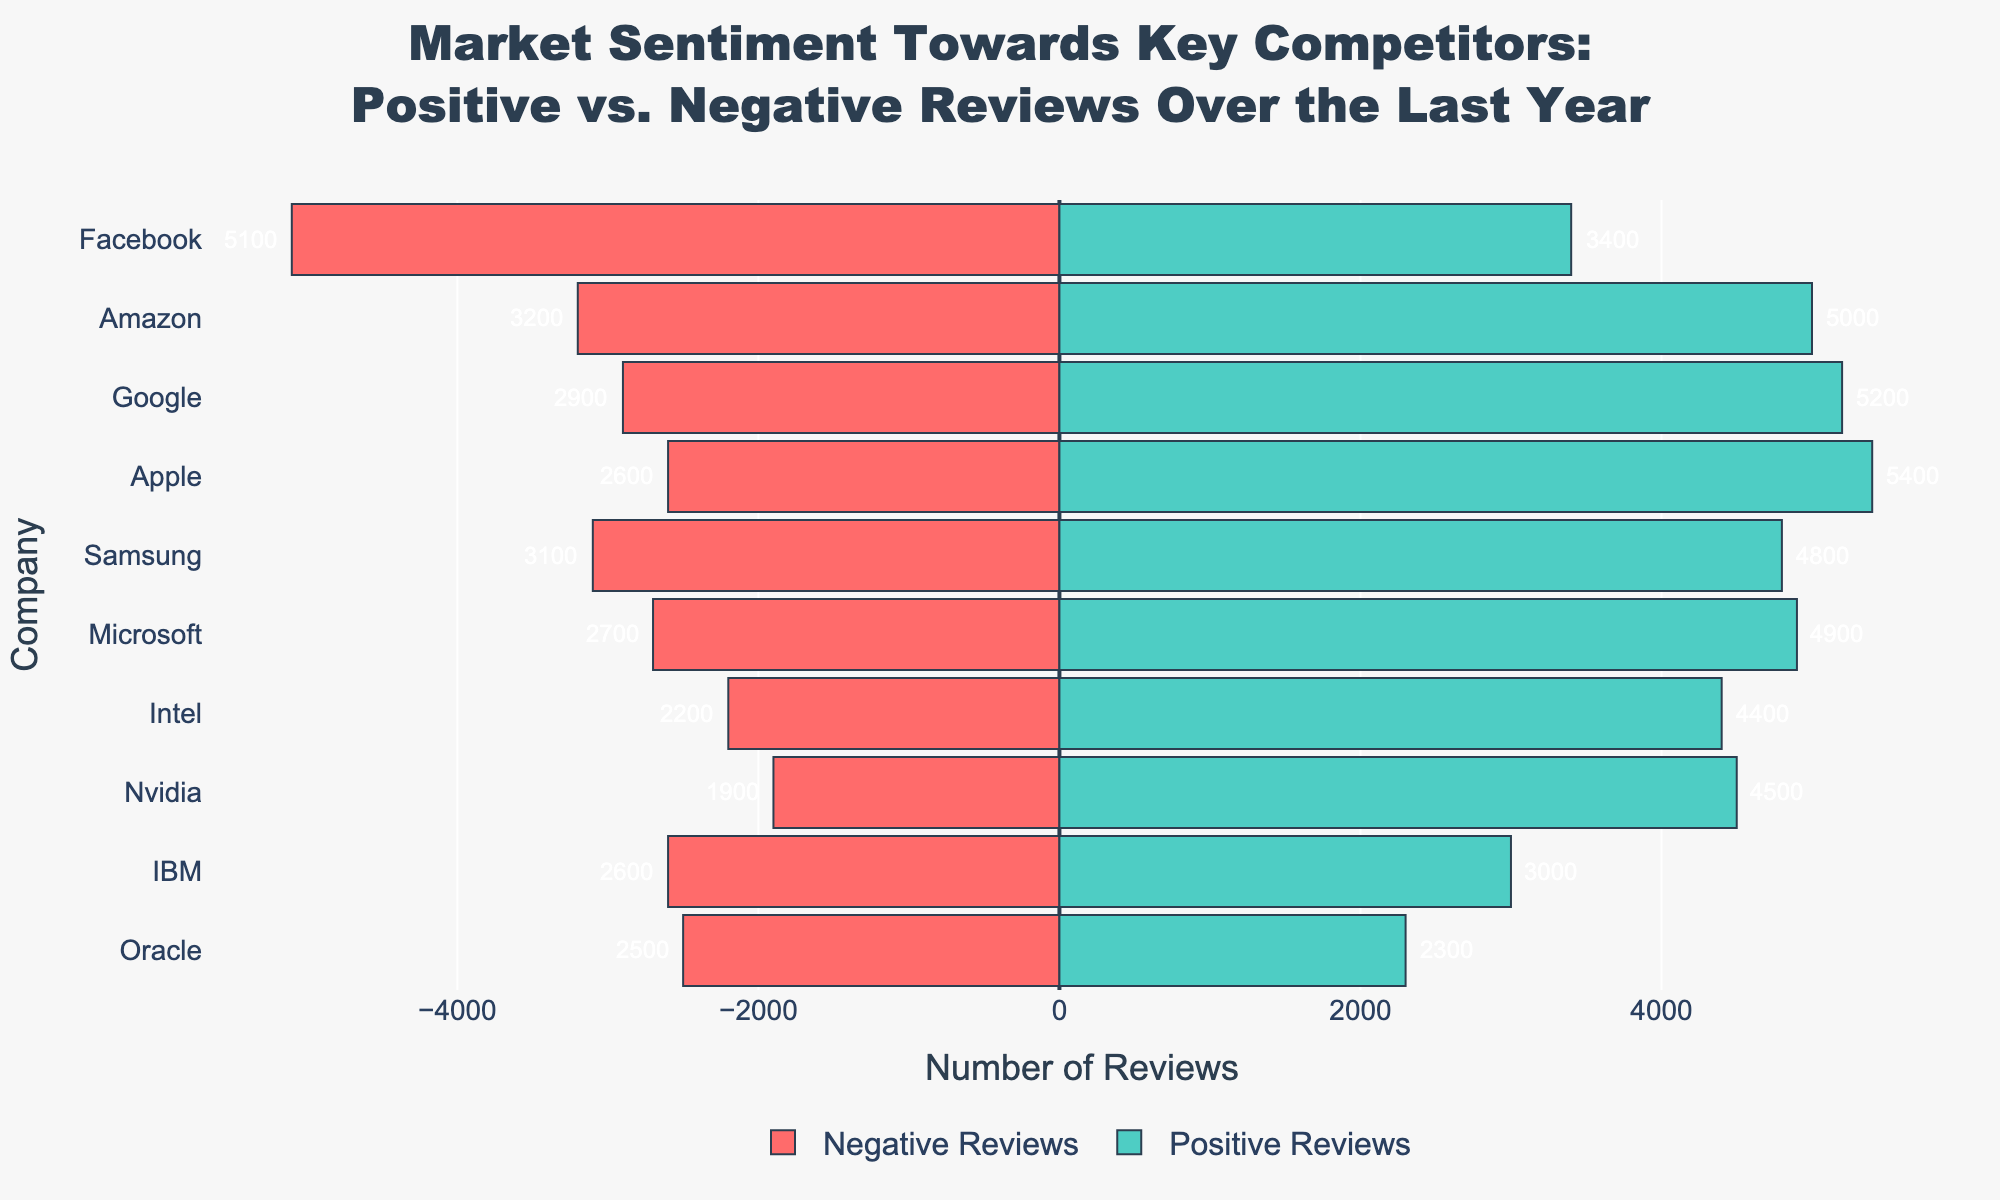What company has the highest number of positive reviews? The highest positive reviews can be identified by the green bar extending furthest to the right. Apple has the green bar extending to 5400, which is the highest positive review number.
Answer: Apple Which company has the highest proportion of negative reviews relative to its total reviews? To find the highest proportion of negative reviews, calculate the ratio of negative reviews to total reviews for each company, then compare. The highest proportion is for Facebook with 5100 out of 8500 reviews, giving a ratio of approximately 0.6.
Answer: Facebook How many more positive reviews does Google have compared to Samsung? Google's positive reviews are 5200, and Samsung's positive reviews are 4800. Subtract Samsung's positive reviews from Google's. 5200 - 4800 = 400.
Answer: 400 What is the average number of positive reviews across all companies? Sum the positive reviews for all companies and divide by the total number of companies. The sum is 48000 and there are 10 companies. The average is 48000 / 10 = 4800.
Answer: 4800 Which company has fewer negative reviews: IBM or Oracle? Compare the red bars for IBM and Oracle. IBM has 2600 negative reviews, and Oracle has 2500 negative reviews. Oracle has fewer negative reviews.
Answer: Oracle What is the difference in total reviews between Amazon and Intel? Calculate the total reviews for Amazon and Intel. Amazon has 8200 and Intel has 6600. Subtract Intel's total from Amazon's: 8200 - 6600 = 1600.
Answer: 1600 Which two companies have a similar number of total reviews? Look for companies with almost equal length bars of combined green and red. Microsoft and Nvidia both have around 7600 total reviews. Microsoft has 7600 and Nvidia has 6400.
Answer: Microsoft and Nvidia What percentage of Nvidia's reviews are positive? Calculate the proportion of positive reviews to total reviews and multiply by 100. Nvidia has 4500 positive out of 6400 total reviews. (4500/6400) * 100 ≈ 70.3%.
Answer: ~70.3% Which company has the smallest difference between its positive and negative reviews? The difference for each company is calculated by subtracting negative reviews from positive reviews, then identify the smallest value. Oracle has 2300 - 2500 = -200, which is the smallest absolute difference.
Answer: Oracle Which companies have more negative than positive reviews? Identify companies where the red bar is longer than the green bar. Only Facebook has more negative reviews (5100) than positive reviews (3400).
Answer: Facebook 